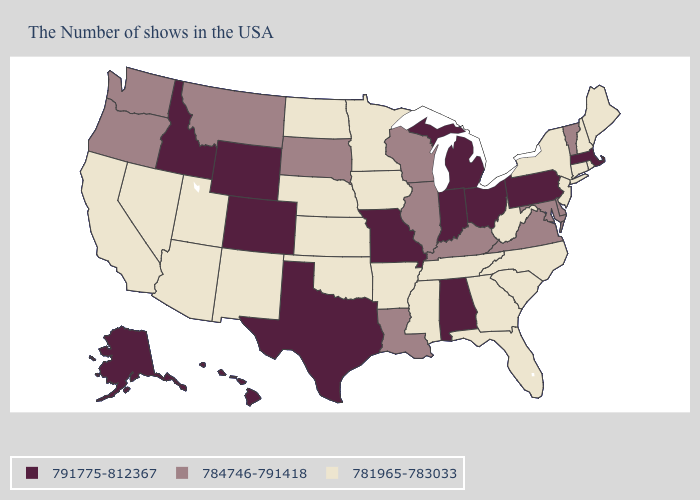What is the highest value in the South ?
Short answer required. 791775-812367. Does New Jersey have the same value as Hawaii?
Keep it brief. No. Is the legend a continuous bar?
Keep it brief. No. Does Hawaii have the highest value in the West?
Write a very short answer. Yes. Which states have the lowest value in the MidWest?
Write a very short answer. Minnesota, Iowa, Kansas, Nebraska, North Dakota. Among the states that border Nevada , does Arizona have the lowest value?
Answer briefly. Yes. Is the legend a continuous bar?
Write a very short answer. No. Name the states that have a value in the range 791775-812367?
Quick response, please. Massachusetts, Pennsylvania, Ohio, Michigan, Indiana, Alabama, Missouri, Texas, Wyoming, Colorado, Idaho, Alaska, Hawaii. Among the states that border New Hampshire , does Maine have the highest value?
Keep it brief. No. Among the states that border Utah , which have the highest value?
Give a very brief answer. Wyoming, Colorado, Idaho. What is the value of Georgia?
Keep it brief. 781965-783033. Does New York have the highest value in the Northeast?
Keep it brief. No. What is the highest value in the South ?
Give a very brief answer. 791775-812367. What is the value of Nevada?
Keep it brief. 781965-783033. What is the lowest value in states that border Delaware?
Be succinct. 781965-783033. 